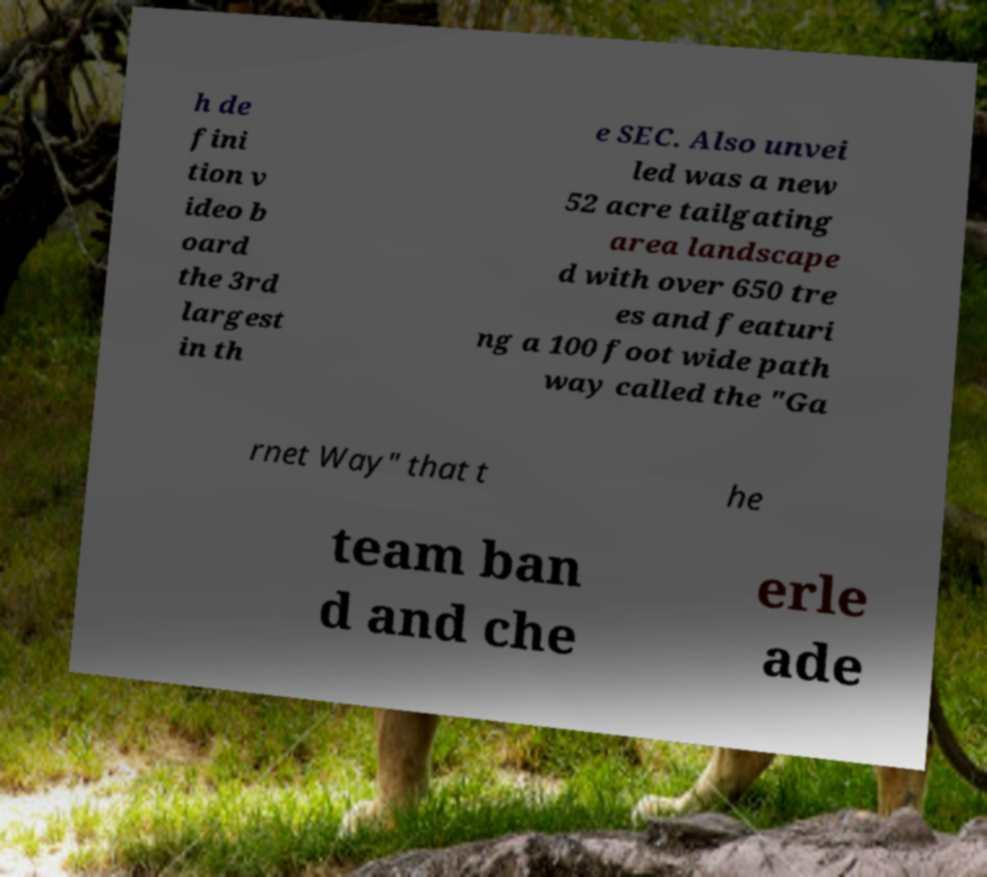Please read and relay the text visible in this image. What does it say? h de fini tion v ideo b oard the 3rd largest in th e SEC. Also unvei led was a new 52 acre tailgating area landscape d with over 650 tre es and featuri ng a 100 foot wide path way called the "Ga rnet Way" that t he team ban d and che erle ade 